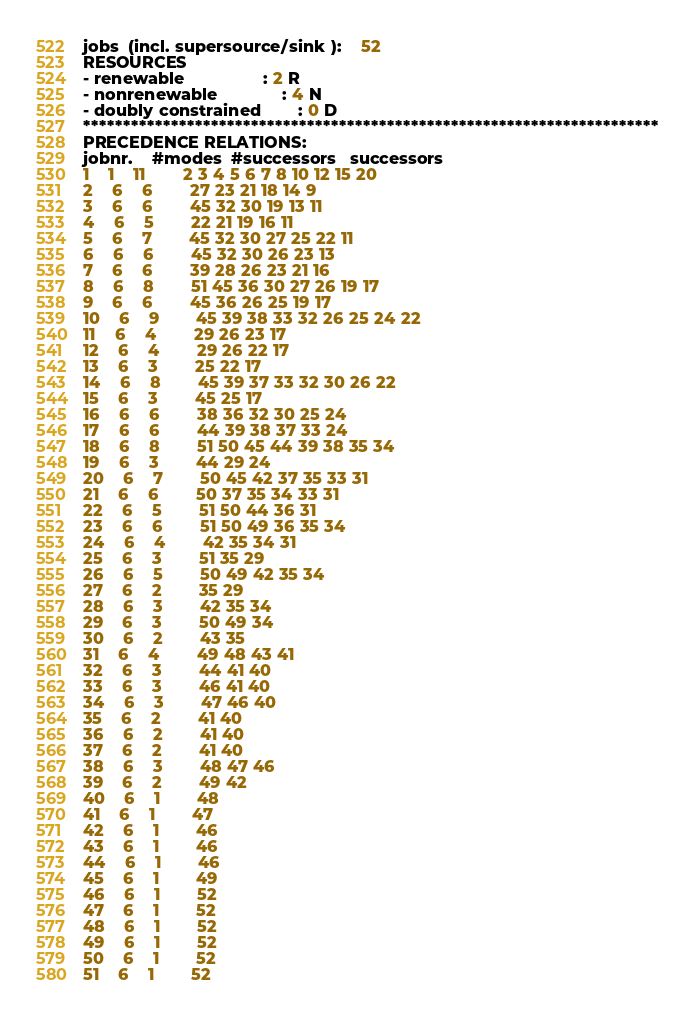Convert code to text. <code><loc_0><loc_0><loc_500><loc_500><_ObjectiveC_>jobs  (incl. supersource/sink ):	52
RESOURCES
- renewable                 : 2 R
- nonrenewable              : 4 N
- doubly constrained        : 0 D
************************************************************************
PRECEDENCE RELATIONS:
jobnr.    #modes  #successors   successors
1	1	11		2 3 4 5 6 7 8 10 12 15 20 
2	6	6		27 23 21 18 14 9 
3	6	6		45 32 30 19 13 11 
4	6	5		22 21 19 16 11 
5	6	7		45 32 30 27 25 22 11 
6	6	6		45 32 30 26 23 13 
7	6	6		39 28 26 23 21 16 
8	6	8		51 45 36 30 27 26 19 17 
9	6	6		45 36 26 25 19 17 
10	6	9		45 39 38 33 32 26 25 24 22 
11	6	4		29 26 23 17 
12	6	4		29 26 22 17 
13	6	3		25 22 17 
14	6	8		45 39 37 33 32 30 26 22 
15	6	3		45 25 17 
16	6	6		38 36 32 30 25 24 
17	6	6		44 39 38 37 33 24 
18	6	8		51 50 45 44 39 38 35 34 
19	6	3		44 29 24 
20	6	7		50 45 42 37 35 33 31 
21	6	6		50 37 35 34 33 31 
22	6	5		51 50 44 36 31 
23	6	6		51 50 49 36 35 34 
24	6	4		42 35 34 31 
25	6	3		51 35 29 
26	6	5		50 49 42 35 34 
27	6	2		35 29 
28	6	3		42 35 34 
29	6	3		50 49 34 
30	6	2		43 35 
31	6	4		49 48 43 41 
32	6	3		44 41 40 
33	6	3		46 41 40 
34	6	3		47 46 40 
35	6	2		41 40 
36	6	2		41 40 
37	6	2		41 40 
38	6	3		48 47 46 
39	6	2		49 42 
40	6	1		48 
41	6	1		47 
42	6	1		46 
43	6	1		46 
44	6	1		46 
45	6	1		49 
46	6	1		52 
47	6	1		52 
48	6	1		52 
49	6	1		52 
50	6	1		52 
51	6	1		52 </code> 